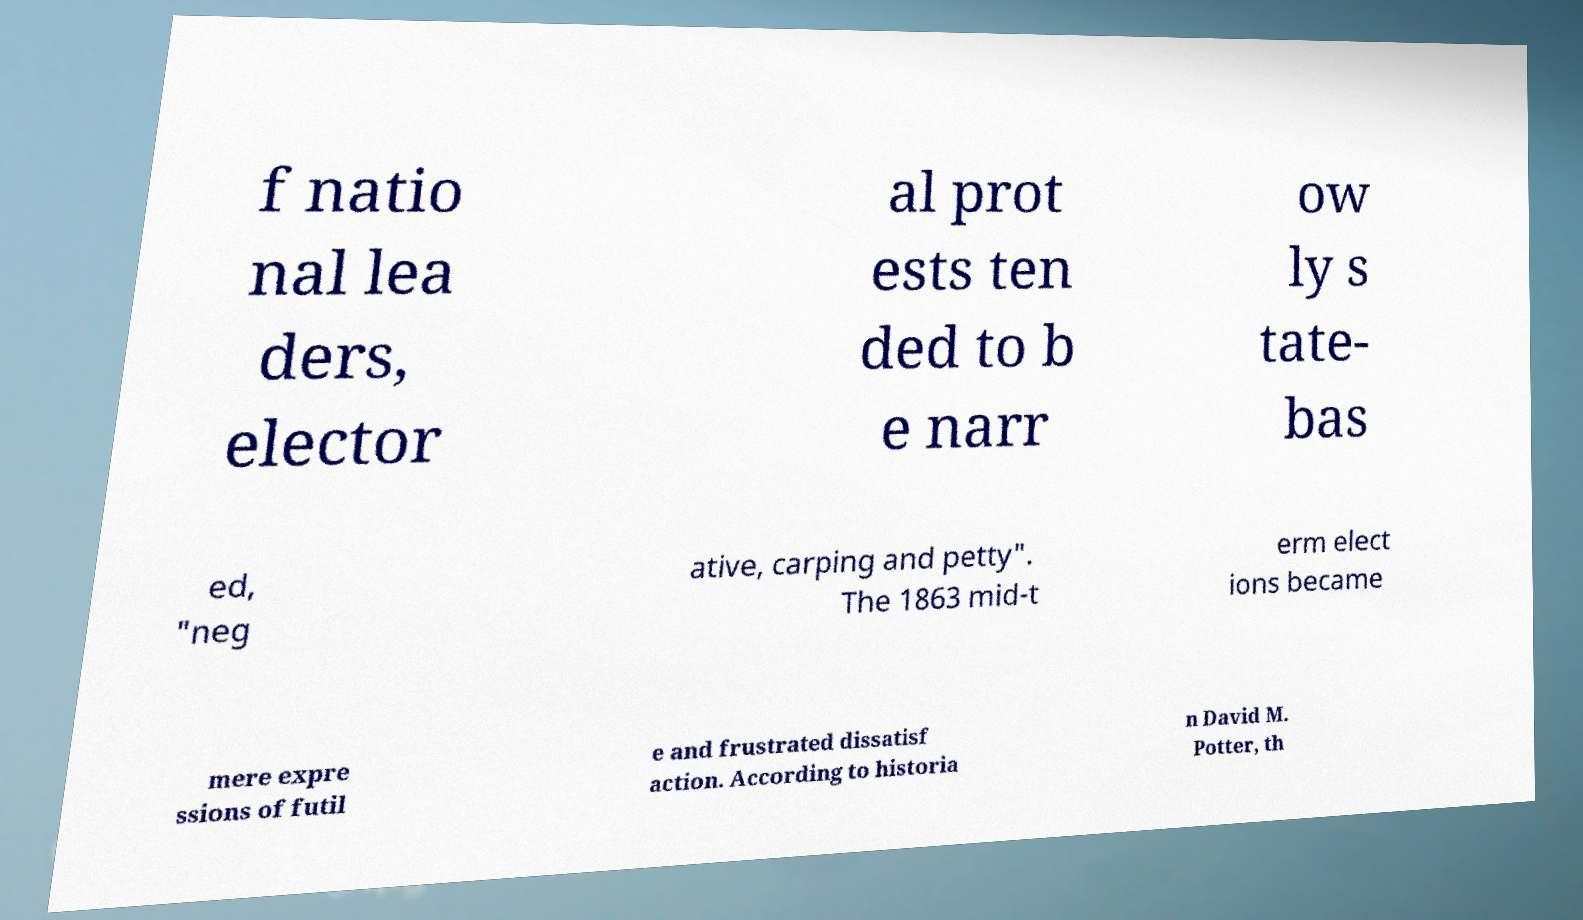Please identify and transcribe the text found in this image. f natio nal lea ders, elector al prot ests ten ded to b e narr ow ly s tate- bas ed, "neg ative, carping and petty". The 1863 mid-t erm elect ions became mere expre ssions of futil e and frustrated dissatisf action. According to historia n David M. Potter, th 